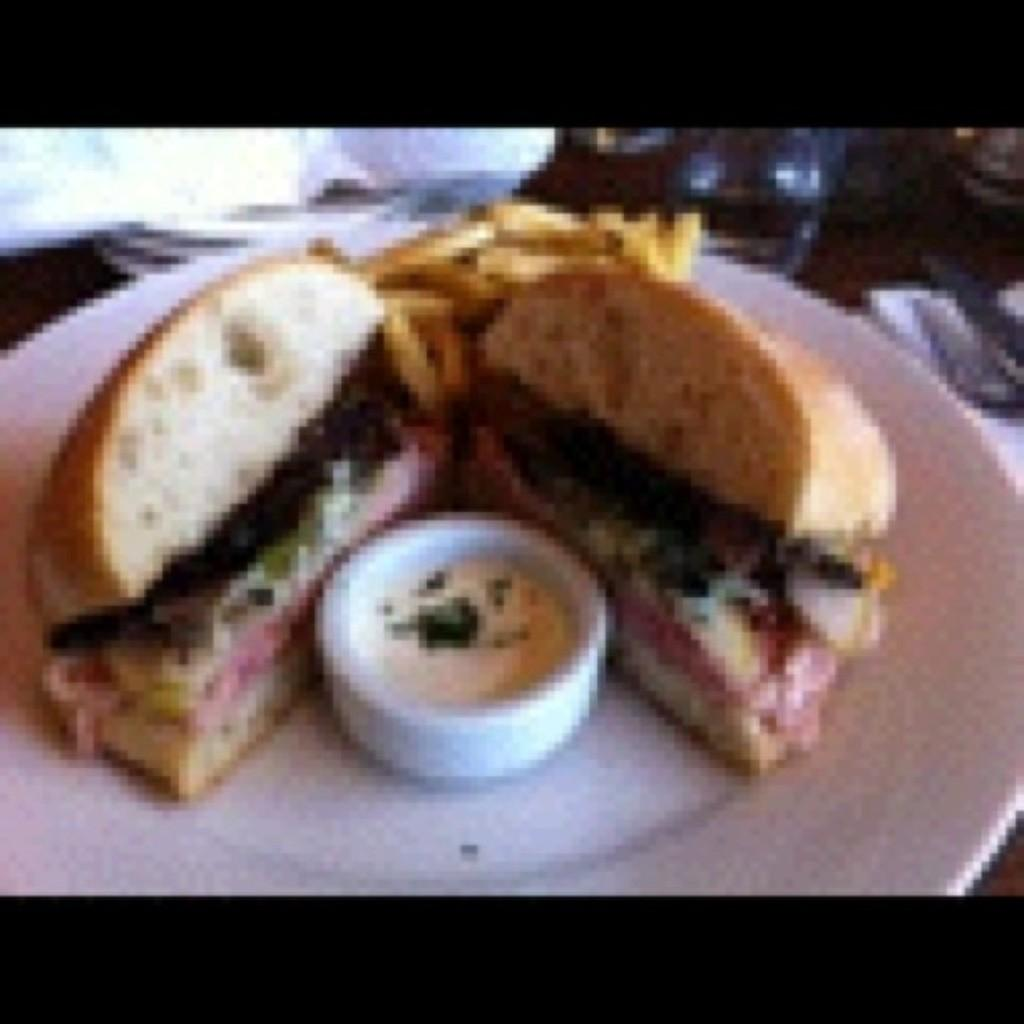What is on the plate that is visible in the image? There is food in a plate in the image. Where is the plate located in the image? The plate is placed on a table. Can you describe the person in the background of the image? Unfortunately, the provided facts do not give any information about the person in the background. What is the sister saying good-bye to the friend in the image? There is no sister or friend present in the image, and therefore no such interaction can be observed. 